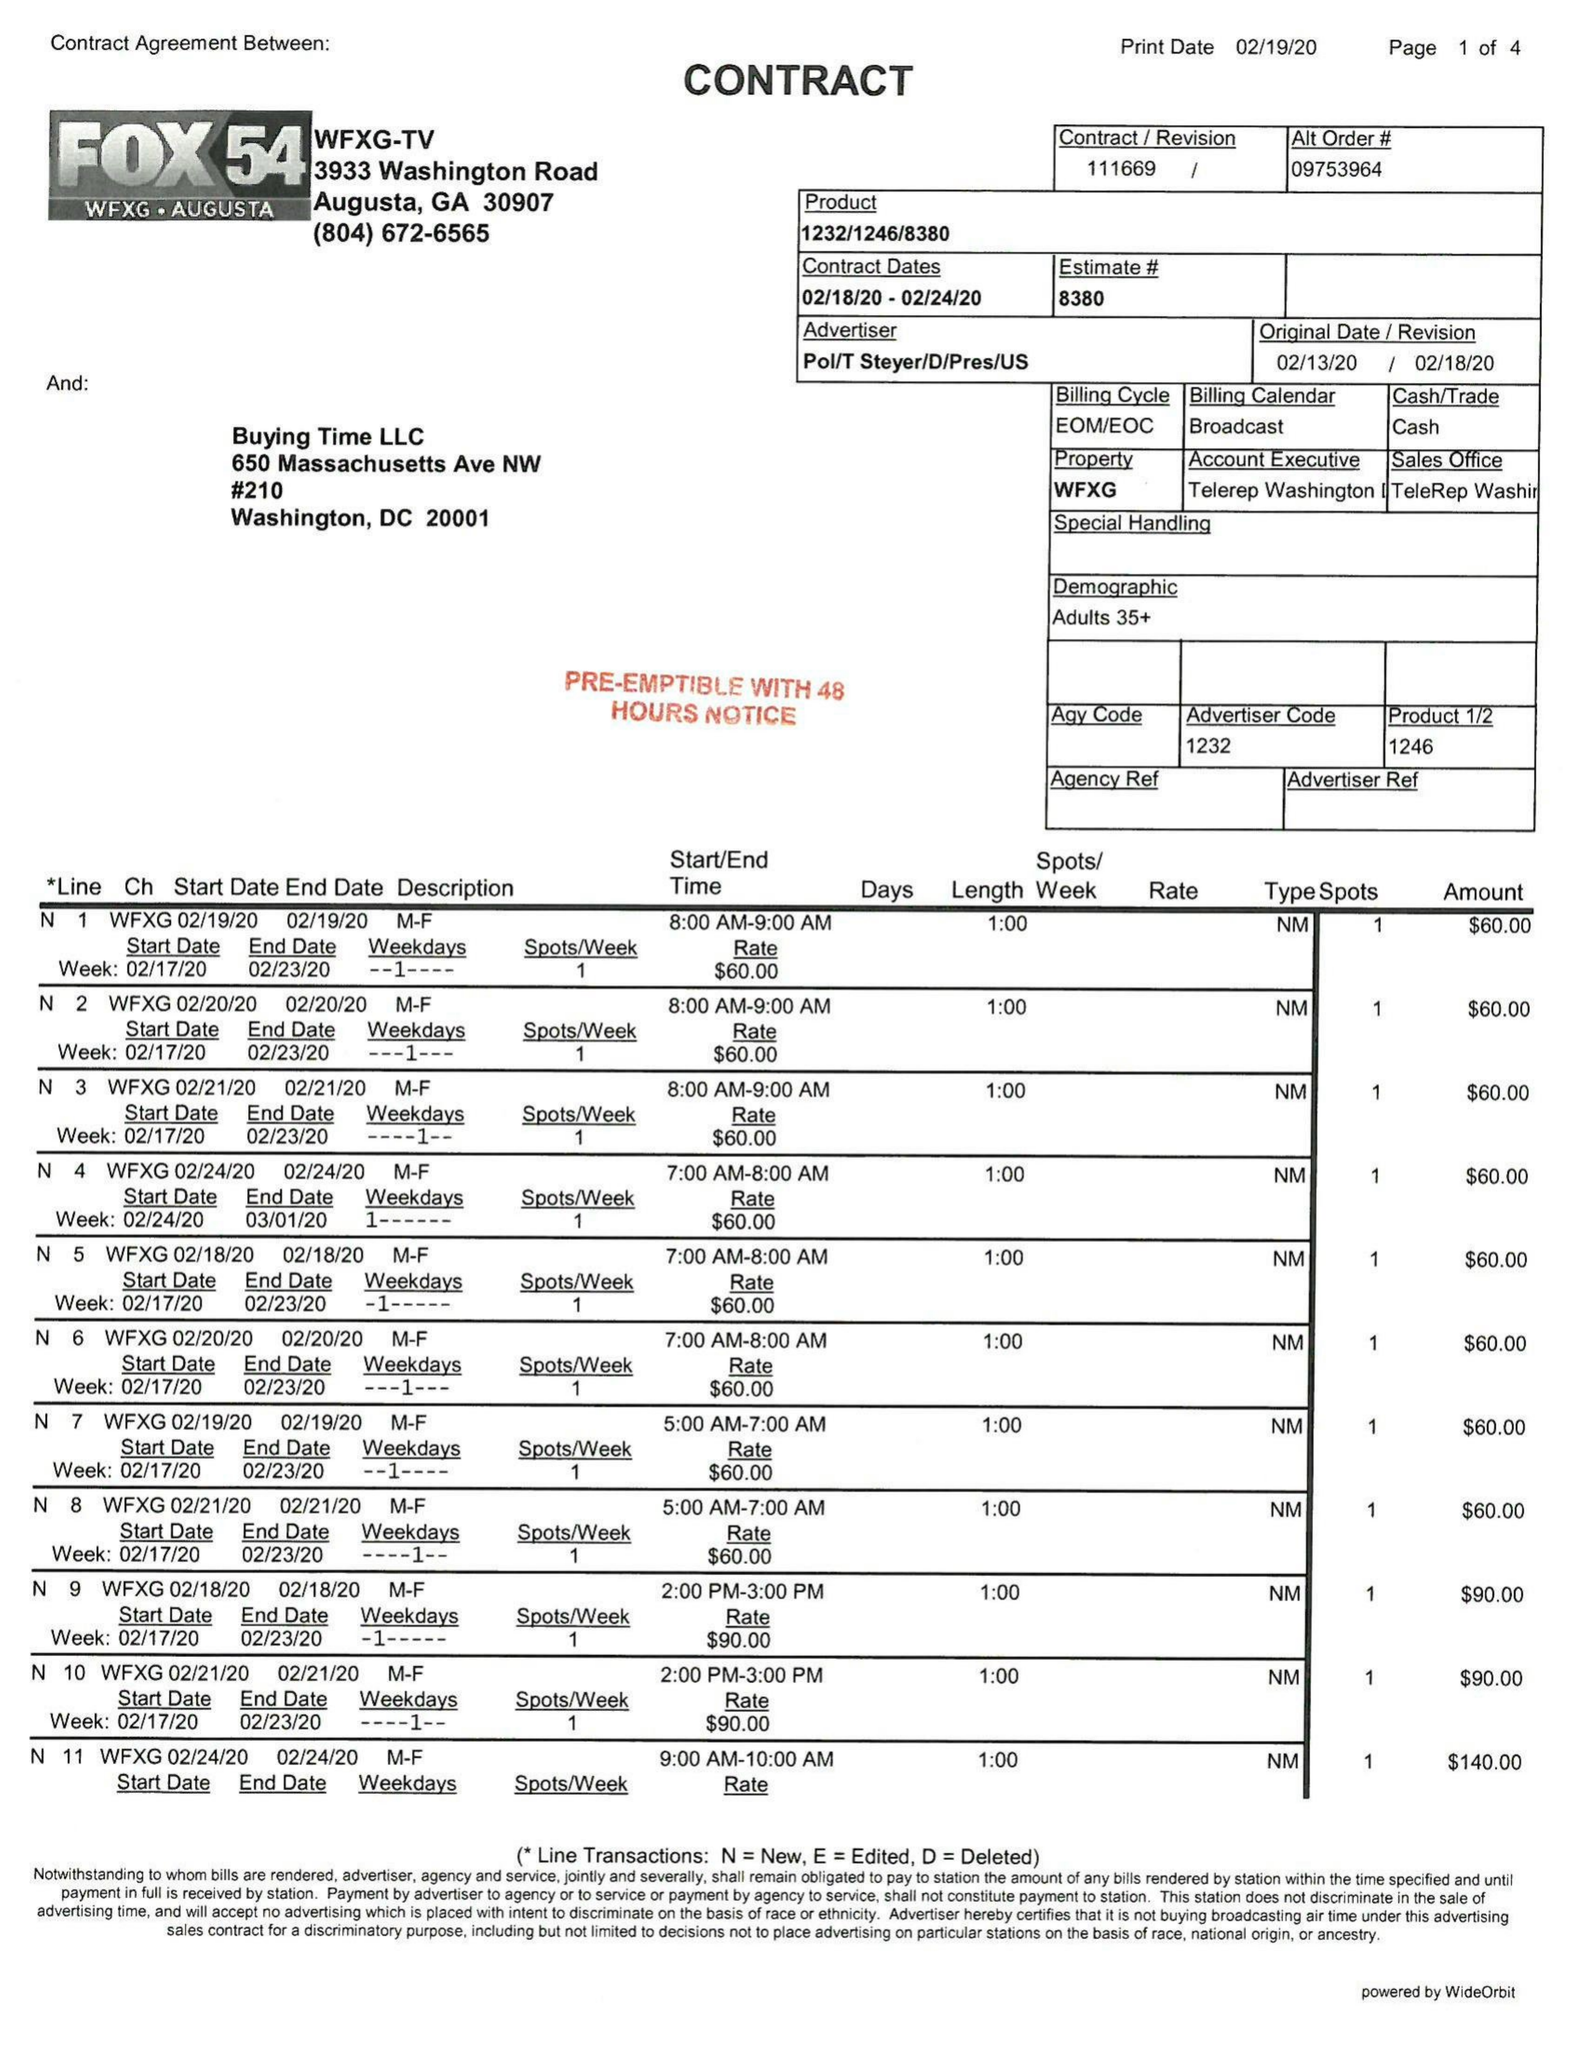What is the value for the flight_to?
Answer the question using a single word or phrase. 02/24/20 